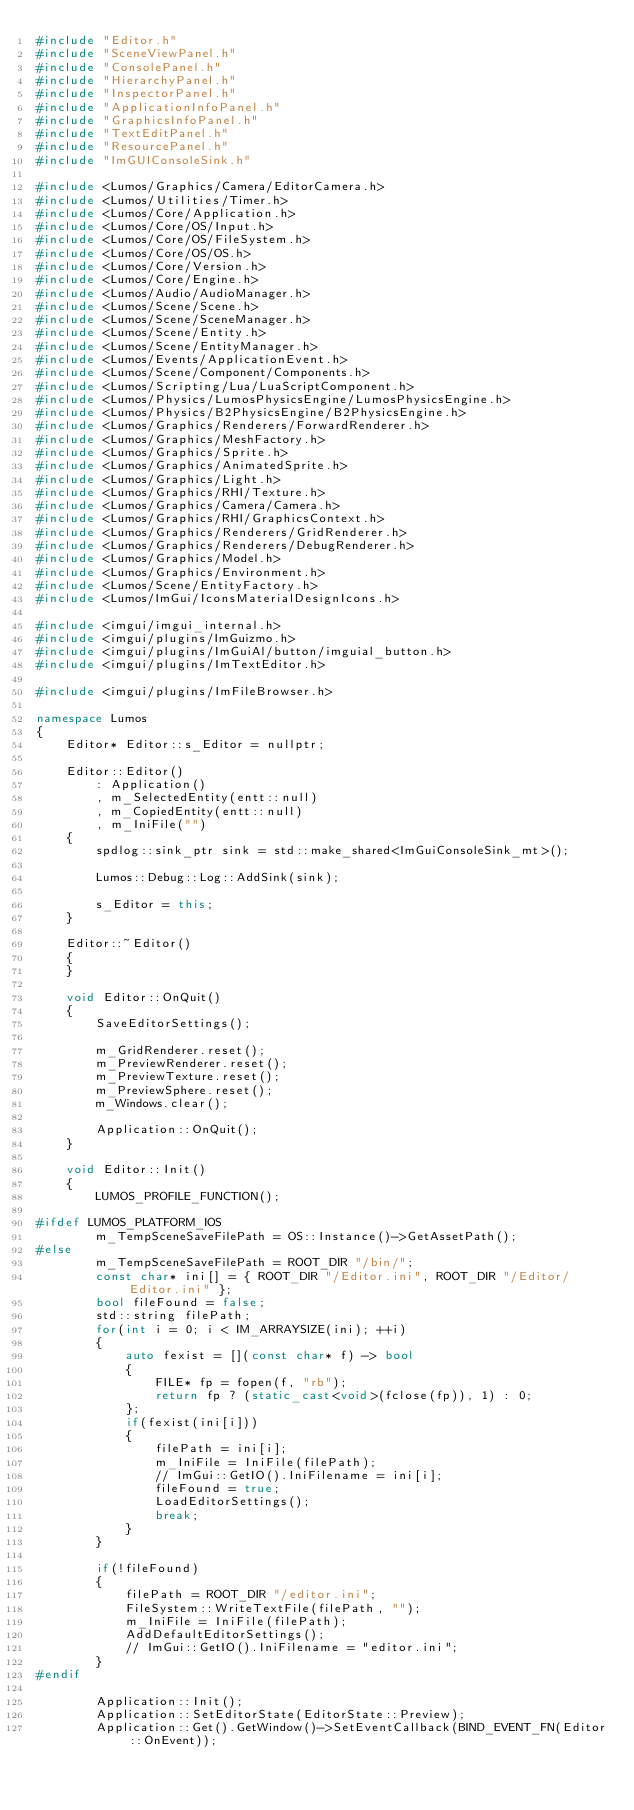<code> <loc_0><loc_0><loc_500><loc_500><_C++_>#include "Editor.h"
#include "SceneViewPanel.h"
#include "ConsolePanel.h"
#include "HierarchyPanel.h"
#include "InspectorPanel.h"
#include "ApplicationInfoPanel.h"
#include "GraphicsInfoPanel.h"
#include "TextEditPanel.h"
#include "ResourcePanel.h"
#include "ImGUIConsoleSink.h"

#include <Lumos/Graphics/Camera/EditorCamera.h>
#include <Lumos/Utilities/Timer.h>
#include <Lumos/Core/Application.h>
#include <Lumos/Core/OS/Input.h>
#include <Lumos/Core/OS/FileSystem.h>
#include <Lumos/Core/OS/OS.h>
#include <Lumos/Core/Version.h>
#include <Lumos/Core/Engine.h>
#include <Lumos/Audio/AudioManager.h>
#include <Lumos/Scene/Scene.h>
#include <Lumos/Scene/SceneManager.h>
#include <Lumos/Scene/Entity.h>
#include <Lumos/Scene/EntityManager.h>
#include <Lumos/Events/ApplicationEvent.h>
#include <Lumos/Scene/Component/Components.h>
#include <Lumos/Scripting/Lua/LuaScriptComponent.h>
#include <Lumos/Physics/LumosPhysicsEngine/LumosPhysicsEngine.h>
#include <Lumos/Physics/B2PhysicsEngine/B2PhysicsEngine.h>
#include <Lumos/Graphics/Renderers/ForwardRenderer.h>
#include <Lumos/Graphics/MeshFactory.h>
#include <Lumos/Graphics/Sprite.h>
#include <Lumos/Graphics/AnimatedSprite.h>
#include <Lumos/Graphics/Light.h>
#include <Lumos/Graphics/RHI/Texture.h>
#include <Lumos/Graphics/Camera/Camera.h>
#include <Lumos/Graphics/RHI/GraphicsContext.h>
#include <Lumos/Graphics/Renderers/GridRenderer.h>
#include <Lumos/Graphics/Renderers/DebugRenderer.h>
#include <Lumos/Graphics/Model.h>
#include <Lumos/Graphics/Environment.h>
#include <Lumos/Scene/EntityFactory.h>
#include <Lumos/ImGui/IconsMaterialDesignIcons.h>

#include <imgui/imgui_internal.h>
#include <imgui/plugins/ImGuizmo.h>
#include <imgui/plugins/ImGuiAl/button/imguial_button.h>
#include <imgui/plugins/ImTextEditor.h>

#include <imgui/plugins/ImFileBrowser.h>

namespace Lumos
{
    Editor* Editor::s_Editor = nullptr;

    Editor::Editor()
        : Application()
        , m_SelectedEntity(entt::null)
        , m_CopiedEntity(entt::null)
        , m_IniFile("")
    {
        spdlog::sink_ptr sink = std::make_shared<ImGuiConsoleSink_mt>();

        Lumos::Debug::Log::AddSink(sink);

        s_Editor = this;
    }

    Editor::~Editor()
    {
    }

    void Editor::OnQuit()
    {
        SaveEditorSettings();

        m_GridRenderer.reset();
        m_PreviewRenderer.reset();
        m_PreviewTexture.reset();
        m_PreviewSphere.reset();
        m_Windows.clear();

        Application::OnQuit();
    }

    void Editor::Init()
    {
        LUMOS_PROFILE_FUNCTION();

#ifdef LUMOS_PLATFORM_IOS
        m_TempSceneSaveFilePath = OS::Instance()->GetAssetPath();
#else
        m_TempSceneSaveFilePath = ROOT_DIR "/bin/";
        const char* ini[] = { ROOT_DIR "/Editor.ini", ROOT_DIR "/Editor/Editor.ini" };
        bool fileFound = false;
        std::string filePath;
        for(int i = 0; i < IM_ARRAYSIZE(ini); ++i)
        {
            auto fexist = [](const char* f) -> bool
            {
                FILE* fp = fopen(f, "rb");
                return fp ? (static_cast<void>(fclose(fp)), 1) : 0;
            };
            if(fexist(ini[i]))
            {
                filePath = ini[i];
                m_IniFile = IniFile(filePath);
                // ImGui::GetIO().IniFilename = ini[i];
                fileFound = true;
                LoadEditorSettings();
                break;
            }
        }

        if(!fileFound)
        {
            filePath = ROOT_DIR "/editor.ini";
            FileSystem::WriteTextFile(filePath, "");
            m_IniFile = IniFile(filePath);
            AddDefaultEditorSettings();
            // ImGui::GetIO().IniFilename = "editor.ini";
        }
#endif

        Application::Init();
        Application::SetEditorState(EditorState::Preview);
        Application::Get().GetWindow()->SetEventCallback(BIND_EVENT_FN(Editor::OnEvent));
</code> 